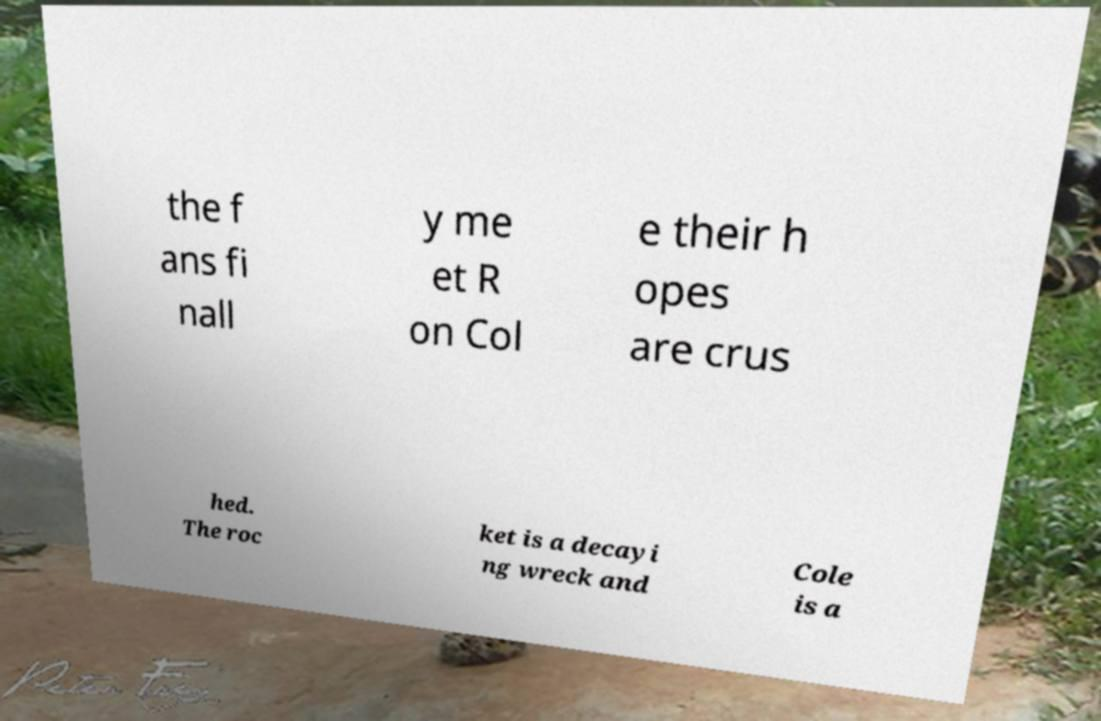What messages or text are displayed in this image? I need them in a readable, typed format. the f ans fi nall y me et R on Col e their h opes are crus hed. The roc ket is a decayi ng wreck and Cole is a 